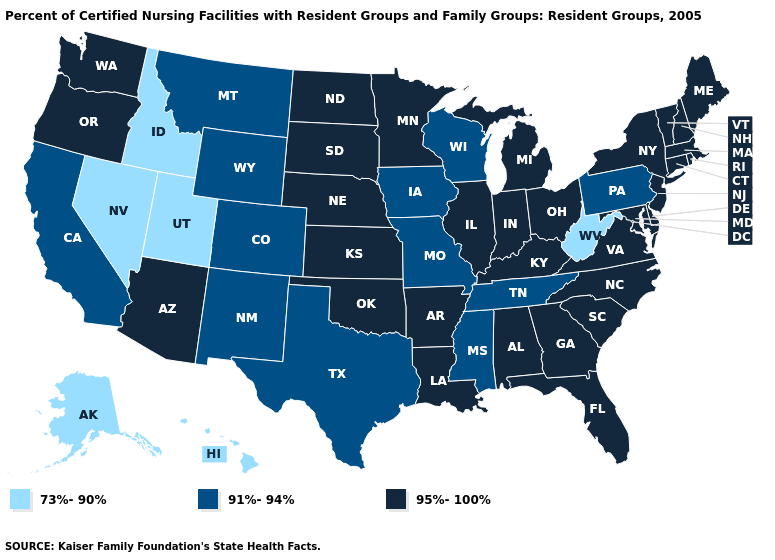Name the states that have a value in the range 73%-90%?
Be succinct. Alaska, Hawaii, Idaho, Nevada, Utah, West Virginia. Does the first symbol in the legend represent the smallest category?
Concise answer only. Yes. Among the states that border South Carolina , which have the highest value?
Write a very short answer. Georgia, North Carolina. Is the legend a continuous bar?
Write a very short answer. No. What is the highest value in the Northeast ?
Write a very short answer. 95%-100%. What is the lowest value in states that border Delaware?
Concise answer only. 91%-94%. Among the states that border Arkansas , which have the lowest value?
Keep it brief. Mississippi, Missouri, Tennessee, Texas. Which states have the lowest value in the USA?
Be succinct. Alaska, Hawaii, Idaho, Nevada, Utah, West Virginia. Does Texas have the lowest value in the USA?
Keep it brief. No. Name the states that have a value in the range 91%-94%?
Write a very short answer. California, Colorado, Iowa, Mississippi, Missouri, Montana, New Mexico, Pennsylvania, Tennessee, Texas, Wisconsin, Wyoming. What is the value of Iowa?
Short answer required. 91%-94%. What is the highest value in the West ?
Keep it brief. 95%-100%. Which states have the lowest value in the USA?
Short answer required. Alaska, Hawaii, Idaho, Nevada, Utah, West Virginia. What is the value of Oregon?
Give a very brief answer. 95%-100%. 